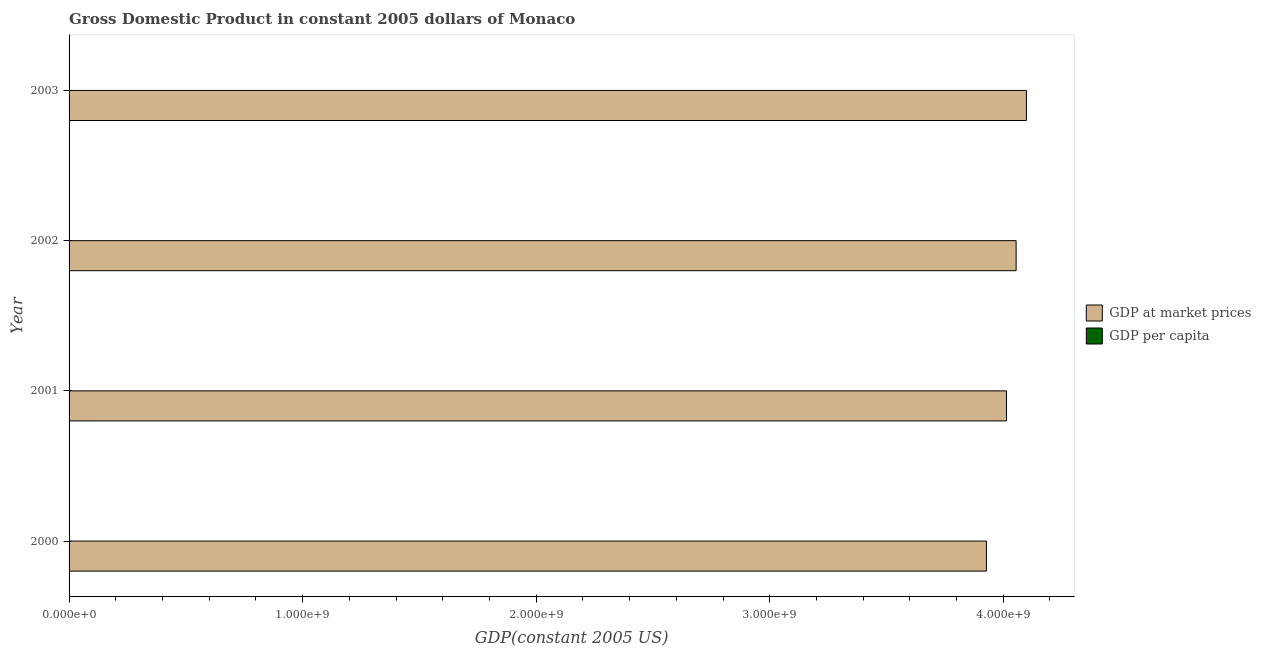How many different coloured bars are there?
Offer a very short reply. 2. Are the number of bars per tick equal to the number of legend labels?
Keep it short and to the point. Yes. Are the number of bars on each tick of the Y-axis equal?
Your answer should be compact. Yes. How many bars are there on the 1st tick from the bottom?
Your answer should be compact. 2. What is the label of the 3rd group of bars from the top?
Give a very brief answer. 2001. What is the gdp per capita in 2001?
Provide a succinct answer. 1.24e+05. Across all years, what is the maximum gdp per capita?
Your answer should be very brief. 1.24e+05. Across all years, what is the minimum gdp per capita?
Your response must be concise. 1.22e+05. In which year was the gdp per capita minimum?
Give a very brief answer. 2000. What is the total gdp per capita in the graph?
Ensure brevity in your answer.  4.95e+05. What is the difference between the gdp at market prices in 2000 and that in 2001?
Keep it short and to the point. -8.59e+07. What is the difference between the gdp at market prices in 2003 and the gdp per capita in 2002?
Offer a very short reply. 4.10e+09. What is the average gdp at market prices per year?
Offer a very short reply. 4.02e+09. In the year 2001, what is the difference between the gdp per capita and gdp at market prices?
Provide a short and direct response. -4.01e+09. What is the ratio of the gdp per capita in 2002 to that in 2003?
Offer a terse response. 1. Is the difference between the gdp per capita in 2000 and 2003 greater than the difference between the gdp at market prices in 2000 and 2003?
Offer a terse response. Yes. What is the difference between the highest and the second highest gdp at market prices?
Your answer should be very brief. 4.41e+07. What is the difference between the highest and the lowest gdp per capita?
Your response must be concise. 1929.99. In how many years, is the gdp per capita greater than the average gdp per capita taken over all years?
Keep it short and to the point. 3. Is the sum of the gdp per capita in 2000 and 2003 greater than the maximum gdp at market prices across all years?
Provide a succinct answer. No. What does the 2nd bar from the top in 2001 represents?
Your answer should be compact. GDP at market prices. What does the 1st bar from the bottom in 2000 represents?
Make the answer very short. GDP at market prices. How many bars are there?
Provide a succinct answer. 8. Are all the bars in the graph horizontal?
Ensure brevity in your answer.  Yes. What is the difference between two consecutive major ticks on the X-axis?
Keep it short and to the point. 1.00e+09. How are the legend labels stacked?
Your response must be concise. Vertical. What is the title of the graph?
Ensure brevity in your answer.  Gross Domestic Product in constant 2005 dollars of Monaco. What is the label or title of the X-axis?
Your response must be concise. GDP(constant 2005 US). What is the GDP(constant 2005 US) in GDP at market prices in 2000?
Your answer should be very brief. 3.93e+09. What is the GDP(constant 2005 US) in GDP per capita in 2000?
Your response must be concise. 1.22e+05. What is the GDP(constant 2005 US) in GDP at market prices in 2001?
Keep it short and to the point. 4.01e+09. What is the GDP(constant 2005 US) in GDP per capita in 2001?
Offer a terse response. 1.24e+05. What is the GDP(constant 2005 US) of GDP at market prices in 2002?
Your response must be concise. 4.06e+09. What is the GDP(constant 2005 US) in GDP per capita in 2002?
Ensure brevity in your answer.  1.24e+05. What is the GDP(constant 2005 US) in GDP at market prices in 2003?
Offer a very short reply. 4.10e+09. What is the GDP(constant 2005 US) of GDP per capita in 2003?
Offer a terse response. 1.24e+05. Across all years, what is the maximum GDP(constant 2005 US) of GDP at market prices?
Provide a succinct answer. 4.10e+09. Across all years, what is the maximum GDP(constant 2005 US) of GDP per capita?
Your answer should be very brief. 1.24e+05. Across all years, what is the minimum GDP(constant 2005 US) in GDP at market prices?
Give a very brief answer. 3.93e+09. Across all years, what is the minimum GDP(constant 2005 US) of GDP per capita?
Give a very brief answer. 1.22e+05. What is the total GDP(constant 2005 US) of GDP at market prices in the graph?
Keep it short and to the point. 1.61e+1. What is the total GDP(constant 2005 US) in GDP per capita in the graph?
Offer a very short reply. 4.95e+05. What is the difference between the GDP(constant 2005 US) of GDP at market prices in 2000 and that in 2001?
Ensure brevity in your answer.  -8.59e+07. What is the difference between the GDP(constant 2005 US) in GDP per capita in 2000 and that in 2001?
Make the answer very short. -1584.56. What is the difference between the GDP(constant 2005 US) in GDP at market prices in 2000 and that in 2002?
Your answer should be very brief. -1.27e+08. What is the difference between the GDP(constant 2005 US) in GDP per capita in 2000 and that in 2002?
Keep it short and to the point. -1767.72. What is the difference between the GDP(constant 2005 US) of GDP at market prices in 2000 and that in 2003?
Offer a terse response. -1.71e+08. What is the difference between the GDP(constant 2005 US) in GDP per capita in 2000 and that in 2003?
Your answer should be very brief. -1929.99. What is the difference between the GDP(constant 2005 US) in GDP at market prices in 2001 and that in 2002?
Make the answer very short. -4.12e+07. What is the difference between the GDP(constant 2005 US) in GDP per capita in 2001 and that in 2002?
Provide a short and direct response. -183.16. What is the difference between the GDP(constant 2005 US) in GDP at market prices in 2001 and that in 2003?
Keep it short and to the point. -8.53e+07. What is the difference between the GDP(constant 2005 US) in GDP per capita in 2001 and that in 2003?
Make the answer very short. -345.42. What is the difference between the GDP(constant 2005 US) of GDP at market prices in 2002 and that in 2003?
Give a very brief answer. -4.41e+07. What is the difference between the GDP(constant 2005 US) in GDP per capita in 2002 and that in 2003?
Provide a short and direct response. -162.26. What is the difference between the GDP(constant 2005 US) of GDP at market prices in 2000 and the GDP(constant 2005 US) of GDP per capita in 2001?
Ensure brevity in your answer.  3.93e+09. What is the difference between the GDP(constant 2005 US) in GDP at market prices in 2000 and the GDP(constant 2005 US) in GDP per capita in 2002?
Offer a terse response. 3.93e+09. What is the difference between the GDP(constant 2005 US) in GDP at market prices in 2000 and the GDP(constant 2005 US) in GDP per capita in 2003?
Provide a short and direct response. 3.93e+09. What is the difference between the GDP(constant 2005 US) in GDP at market prices in 2001 and the GDP(constant 2005 US) in GDP per capita in 2002?
Give a very brief answer. 4.01e+09. What is the difference between the GDP(constant 2005 US) in GDP at market prices in 2001 and the GDP(constant 2005 US) in GDP per capita in 2003?
Your response must be concise. 4.01e+09. What is the difference between the GDP(constant 2005 US) of GDP at market prices in 2002 and the GDP(constant 2005 US) of GDP per capita in 2003?
Offer a very short reply. 4.05e+09. What is the average GDP(constant 2005 US) in GDP at market prices per year?
Your response must be concise. 4.02e+09. What is the average GDP(constant 2005 US) in GDP per capita per year?
Keep it short and to the point. 1.24e+05. In the year 2000, what is the difference between the GDP(constant 2005 US) in GDP at market prices and GDP(constant 2005 US) in GDP per capita?
Your response must be concise. 3.93e+09. In the year 2001, what is the difference between the GDP(constant 2005 US) in GDP at market prices and GDP(constant 2005 US) in GDP per capita?
Offer a very short reply. 4.01e+09. In the year 2002, what is the difference between the GDP(constant 2005 US) in GDP at market prices and GDP(constant 2005 US) in GDP per capita?
Ensure brevity in your answer.  4.05e+09. In the year 2003, what is the difference between the GDP(constant 2005 US) in GDP at market prices and GDP(constant 2005 US) in GDP per capita?
Provide a short and direct response. 4.10e+09. What is the ratio of the GDP(constant 2005 US) of GDP at market prices in 2000 to that in 2001?
Offer a very short reply. 0.98. What is the ratio of the GDP(constant 2005 US) in GDP per capita in 2000 to that in 2001?
Your answer should be compact. 0.99. What is the ratio of the GDP(constant 2005 US) in GDP at market prices in 2000 to that in 2002?
Make the answer very short. 0.97. What is the ratio of the GDP(constant 2005 US) in GDP per capita in 2000 to that in 2002?
Make the answer very short. 0.99. What is the ratio of the GDP(constant 2005 US) in GDP at market prices in 2000 to that in 2003?
Offer a terse response. 0.96. What is the ratio of the GDP(constant 2005 US) in GDP per capita in 2000 to that in 2003?
Keep it short and to the point. 0.98. What is the ratio of the GDP(constant 2005 US) of GDP at market prices in 2001 to that in 2002?
Make the answer very short. 0.99. What is the ratio of the GDP(constant 2005 US) of GDP per capita in 2001 to that in 2002?
Make the answer very short. 1. What is the ratio of the GDP(constant 2005 US) in GDP at market prices in 2001 to that in 2003?
Your answer should be very brief. 0.98. What is the ratio of the GDP(constant 2005 US) in GDP at market prices in 2002 to that in 2003?
Ensure brevity in your answer.  0.99. What is the difference between the highest and the second highest GDP(constant 2005 US) of GDP at market prices?
Offer a terse response. 4.41e+07. What is the difference between the highest and the second highest GDP(constant 2005 US) in GDP per capita?
Offer a terse response. 162.26. What is the difference between the highest and the lowest GDP(constant 2005 US) of GDP at market prices?
Provide a succinct answer. 1.71e+08. What is the difference between the highest and the lowest GDP(constant 2005 US) of GDP per capita?
Your answer should be very brief. 1929.99. 